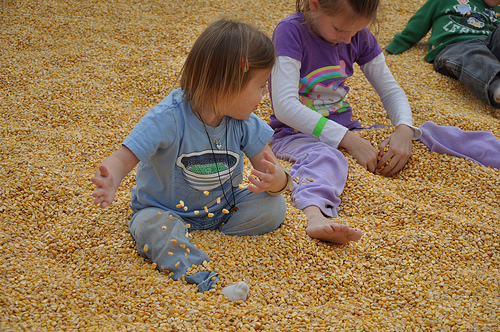<image>
Is there a ground on the girl? No. The ground is not positioned on the girl. They may be near each other, but the ground is not supported by or resting on top of the girl. 